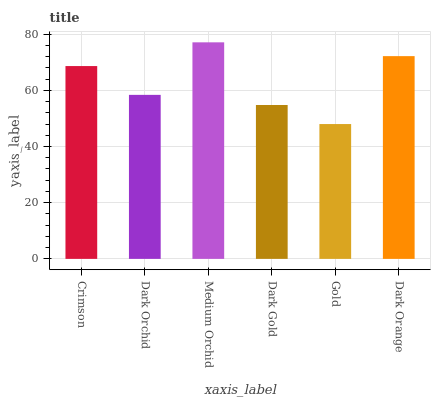Is Gold the minimum?
Answer yes or no. Yes. Is Medium Orchid the maximum?
Answer yes or no. Yes. Is Dark Orchid the minimum?
Answer yes or no. No. Is Dark Orchid the maximum?
Answer yes or no. No. Is Crimson greater than Dark Orchid?
Answer yes or no. Yes. Is Dark Orchid less than Crimson?
Answer yes or no. Yes. Is Dark Orchid greater than Crimson?
Answer yes or no. No. Is Crimson less than Dark Orchid?
Answer yes or no. No. Is Crimson the high median?
Answer yes or no. Yes. Is Dark Orchid the low median?
Answer yes or no. Yes. Is Dark Orchid the high median?
Answer yes or no. No. Is Dark Gold the low median?
Answer yes or no. No. 